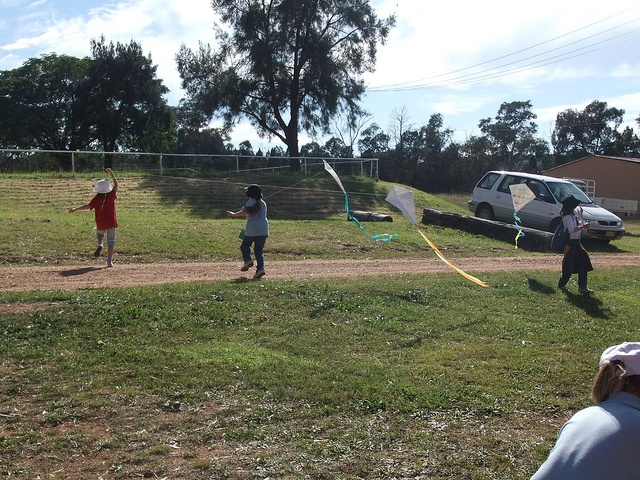Describe the objects in this image and their specific colors. I can see people in lightblue, black, lightgray, and gray tones, car in lightblue, gray, black, darkgray, and blue tones, people in lightblue, black, gray, and maroon tones, people in lightblue, maroon, gray, and black tones, and people in lightblue, black, darkblue, and gray tones in this image. 